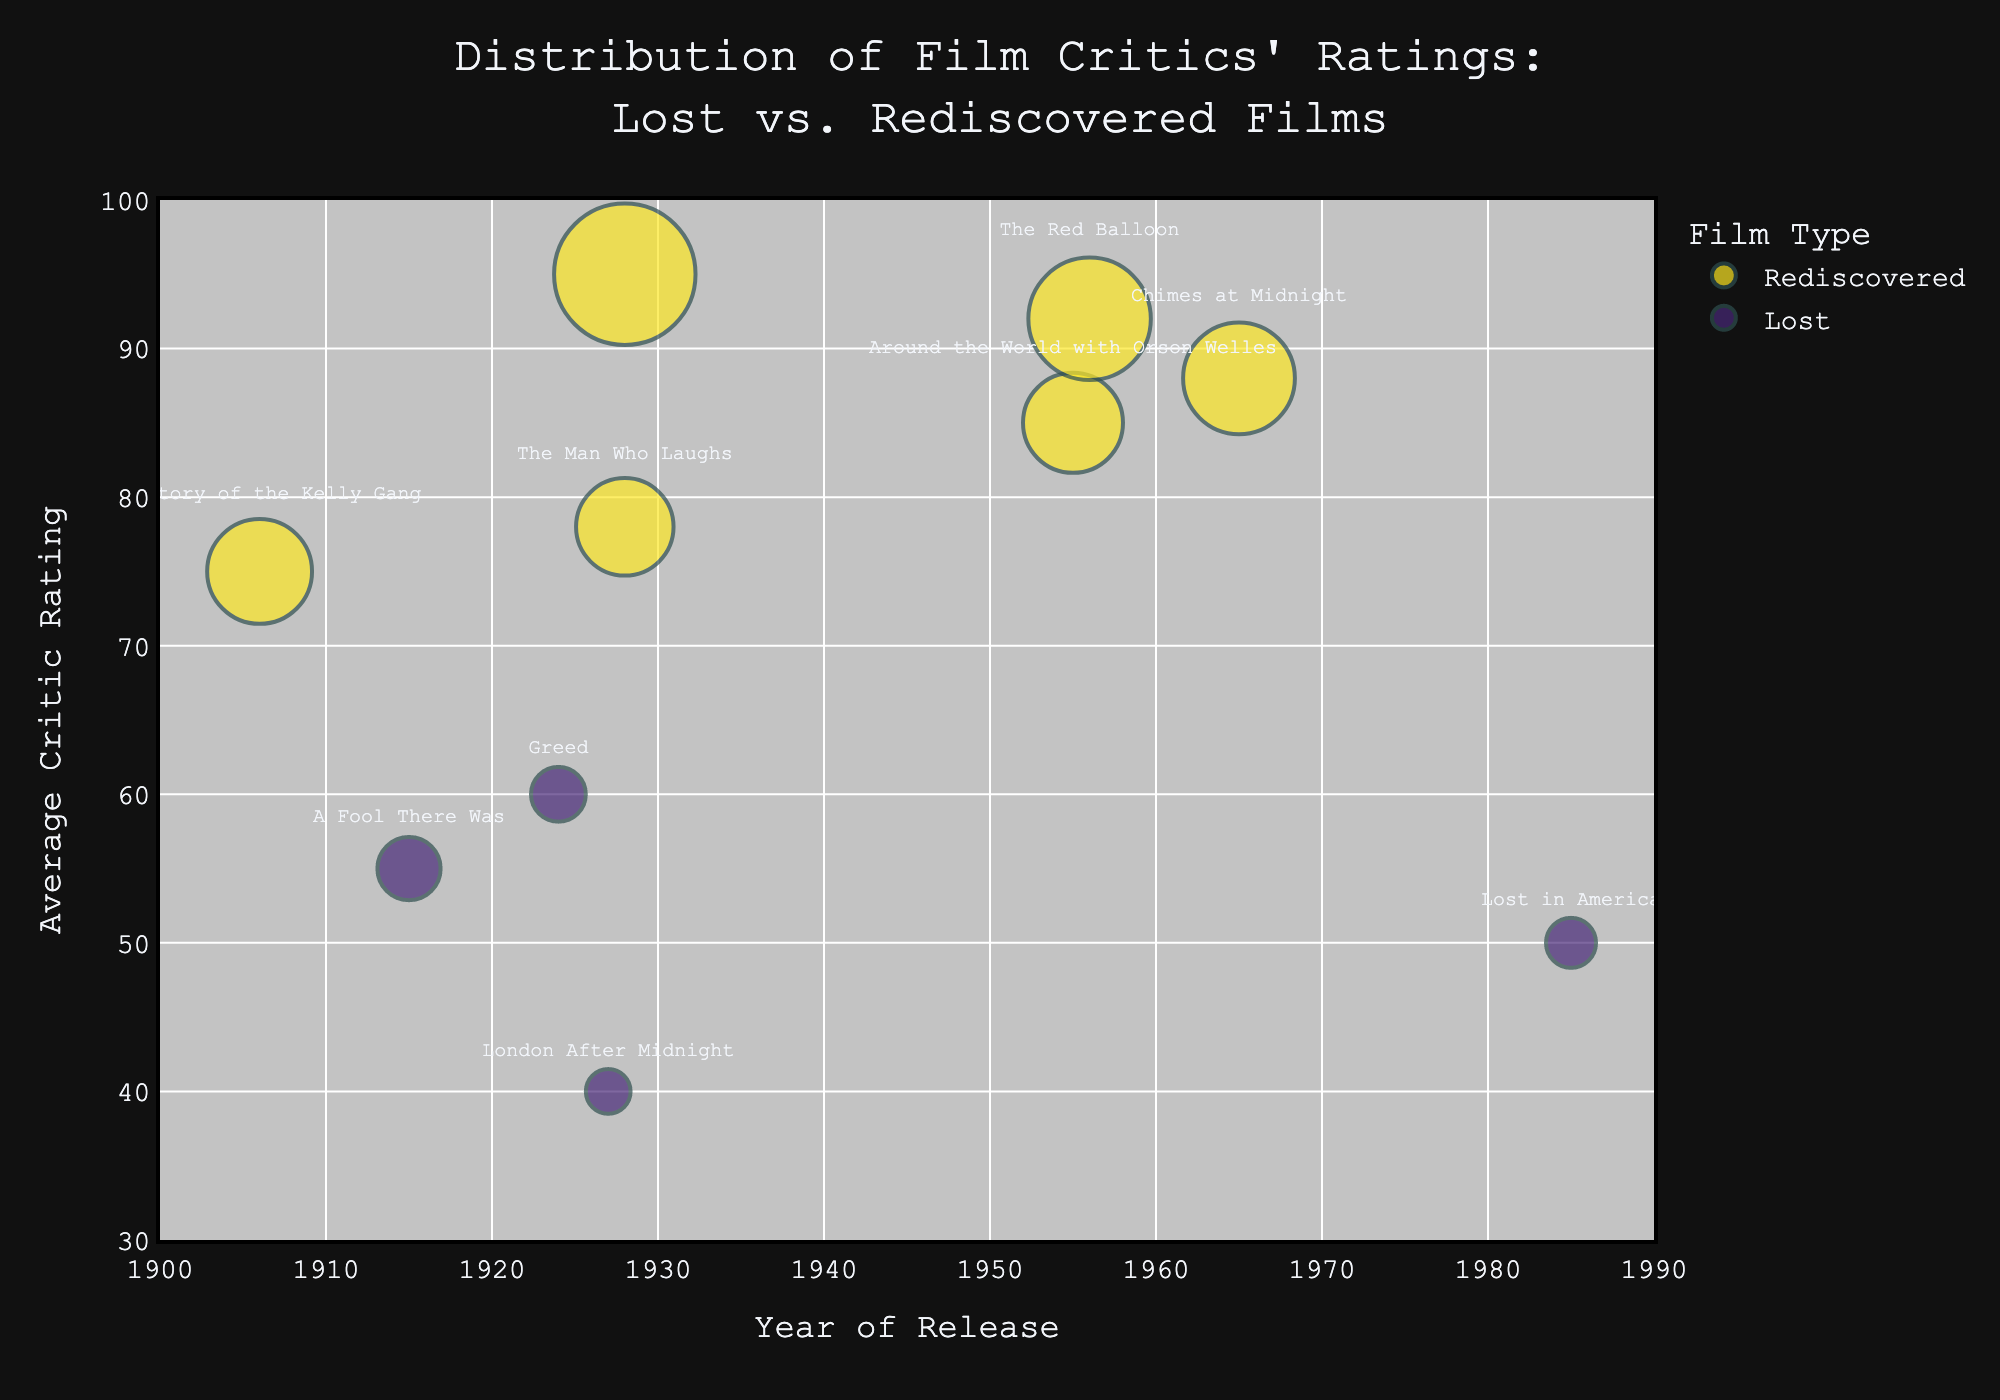Which film has the highest average critic rating? To determine the film with the highest average critic rating, look for the bubble highest up on the y-axis. "The Passion of Joan of Arc" is at the highest point with a rating of 95.
Answer: "The Passion of Joan of Arc" How many films in the chart were released before 1930? Count the number of bubbles to the left of the 1930 mark on the x-axis. There are six films: "London After Midnight", "Greed", "The Passion of Joan of Arc", "The Man Who Laughs", "A Fool There Was", and "The Story of the Kelly Gang".
Answer: Six What is the average rating of rediscovered films? Sum the average ratings of all rediscovered films then divide by the number of rediscovered films. (85 + 92 + 95 + 88 + 78 + 75) / 6 = 85.5
Answer: 85.5 Which type of film has generally received higher ratings from critics? Compare the relative positions of the "Lost" and "Rediscovered" bubbles along the y-axis. The rediscovered films are generally higher up, indicating higher ratings.
Answer: Rediscovered Which film has the largest number of reviews? Find the bubble with the largest size. "The Passion of Joan of Arc" has the largest bubble size, corresponding to 40 reviews.
Answer: "The Passion of Joan of Arc" Are there more lost or rediscovered films in the chart? Count the number of "Lost" and "Rediscovered" films. There are four "Lost" and six "Rediscovered" films.
Answer: Rediscovered What is the difference in average critic rating between "Greed" and "The Story of the Kelly Gang"? Subtract the average rating of "The Story of the Kelly Gang" from "Greed" (75 - 60 = 15).
Answer: 15 Which film has the lowest critic rating? Look for the bubble lowest on the y-axis. "London After Midnight" has a rating of 40, the lowest in the chart.
Answer: "London After Midnight" Compare the average critic ratings of films from the 1920s. Is there a noticeable trend? Calculate the average ratings of all films from the 1920s and compare them. "London After Midnight" (40), "The Passion of Joan of Arc" (95), and "The Man Who Laughs" (78). The spread is wide, from 40 to 95, indicating diversity in critic opinions.
Answer: Diverse (No clear trend) What is the visibility of the film "Lost in America"? The chart shows the opacity of the bubbles, and "Lost in America" has a transparency value of 0.6. Define visibility as opacity, scaling from 0 (transparent) to 1 (opaque).
Answer: 0.6 